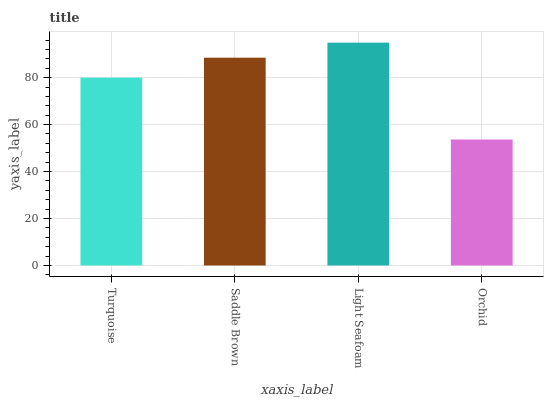Is Orchid the minimum?
Answer yes or no. Yes. Is Light Seafoam the maximum?
Answer yes or no. Yes. Is Saddle Brown the minimum?
Answer yes or no. No. Is Saddle Brown the maximum?
Answer yes or no. No. Is Saddle Brown greater than Turquoise?
Answer yes or no. Yes. Is Turquoise less than Saddle Brown?
Answer yes or no. Yes. Is Turquoise greater than Saddle Brown?
Answer yes or no. No. Is Saddle Brown less than Turquoise?
Answer yes or no. No. Is Saddle Brown the high median?
Answer yes or no. Yes. Is Turquoise the low median?
Answer yes or no. Yes. Is Turquoise the high median?
Answer yes or no. No. Is Light Seafoam the low median?
Answer yes or no. No. 